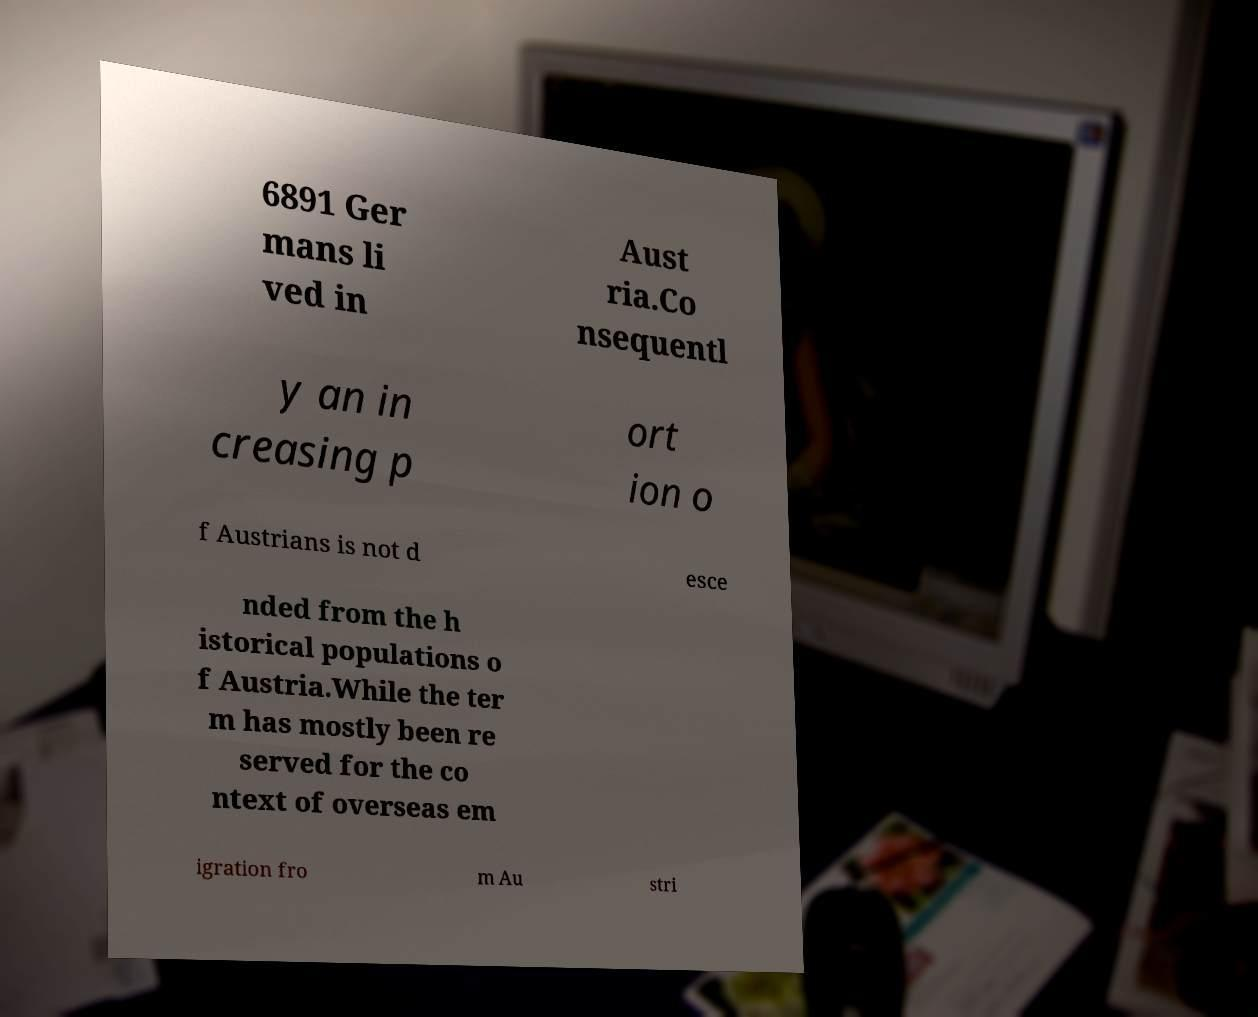For documentation purposes, I need the text within this image transcribed. Could you provide that? 6891 Ger mans li ved in Aust ria.Co nsequentl y an in creasing p ort ion o f Austrians is not d esce nded from the h istorical populations o f Austria.While the ter m has mostly been re served for the co ntext of overseas em igration fro m Au stri 